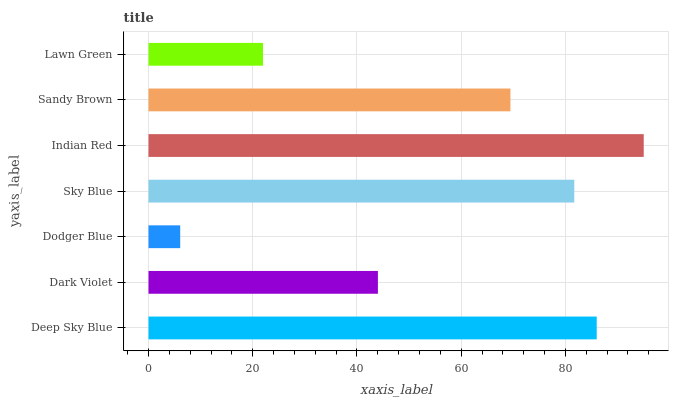Is Dodger Blue the minimum?
Answer yes or no. Yes. Is Indian Red the maximum?
Answer yes or no. Yes. Is Dark Violet the minimum?
Answer yes or no. No. Is Dark Violet the maximum?
Answer yes or no. No. Is Deep Sky Blue greater than Dark Violet?
Answer yes or no. Yes. Is Dark Violet less than Deep Sky Blue?
Answer yes or no. Yes. Is Dark Violet greater than Deep Sky Blue?
Answer yes or no. No. Is Deep Sky Blue less than Dark Violet?
Answer yes or no. No. Is Sandy Brown the high median?
Answer yes or no. Yes. Is Sandy Brown the low median?
Answer yes or no. Yes. Is Dark Violet the high median?
Answer yes or no. No. Is Deep Sky Blue the low median?
Answer yes or no. No. 